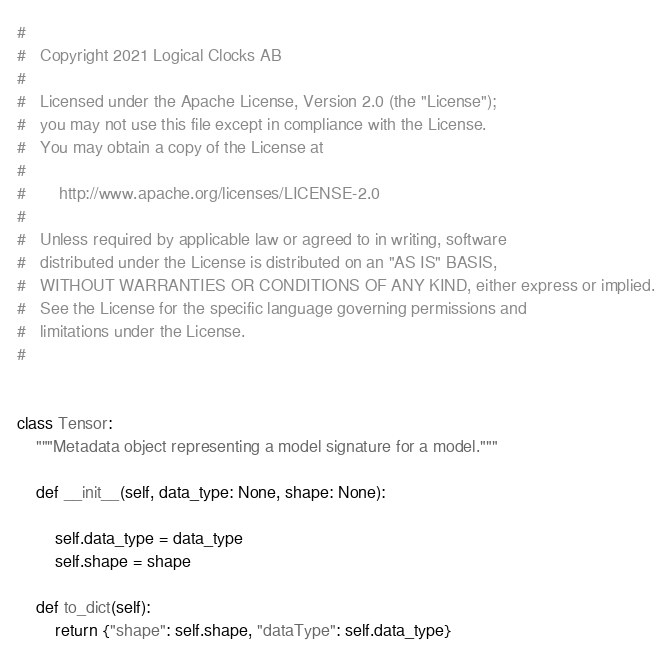<code> <loc_0><loc_0><loc_500><loc_500><_Python_>#
#   Copyright 2021 Logical Clocks AB
#
#   Licensed under the Apache License, Version 2.0 (the "License");
#   you may not use this file except in compliance with the License.
#   You may obtain a copy of the License at
#
#       http://www.apache.org/licenses/LICENSE-2.0
#
#   Unless required by applicable law or agreed to in writing, software
#   distributed under the License is distributed on an "AS IS" BASIS,
#   WITHOUT WARRANTIES OR CONDITIONS OF ANY KIND, either express or implied.
#   See the License for the specific language governing permissions and
#   limitations under the License.
#


class Tensor:
    """Metadata object representing a model signature for a model."""

    def __init__(self, data_type: None, shape: None):

        self.data_type = data_type
        self.shape = shape

    def to_dict(self):
        return {"shape": self.shape, "dataType": self.data_type}
</code> 